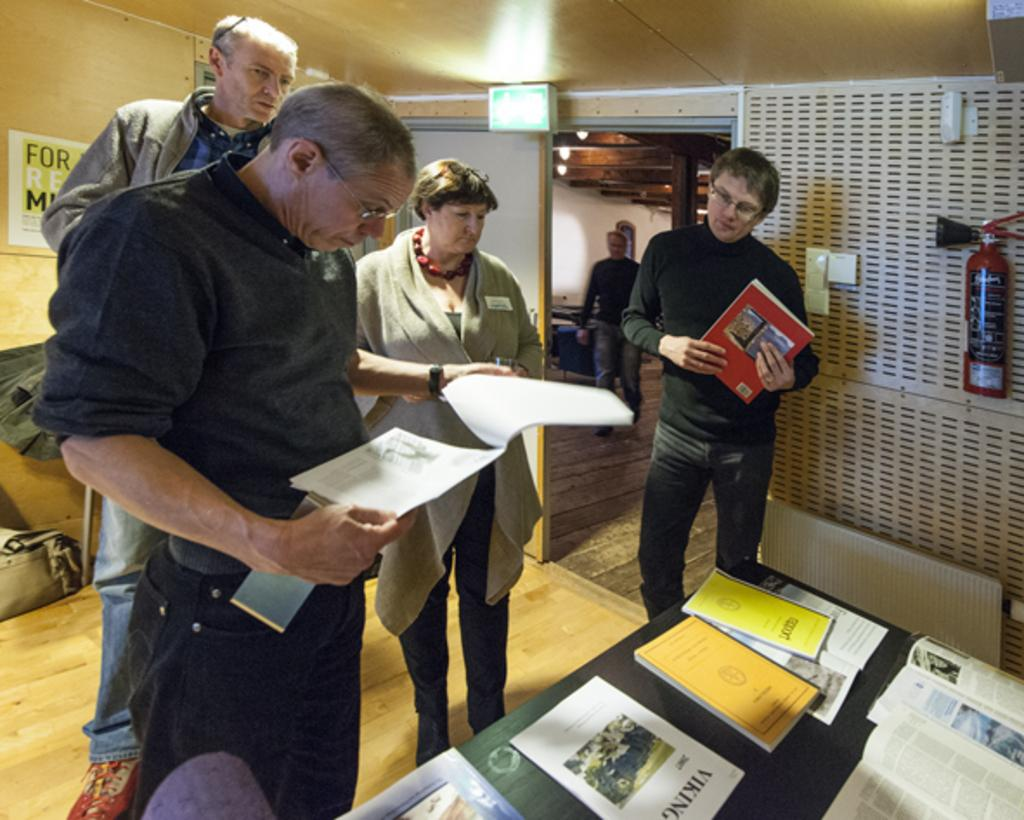Provide a one-sentence caption for the provided image. A group of people looking at books, one of which is about vikings. 